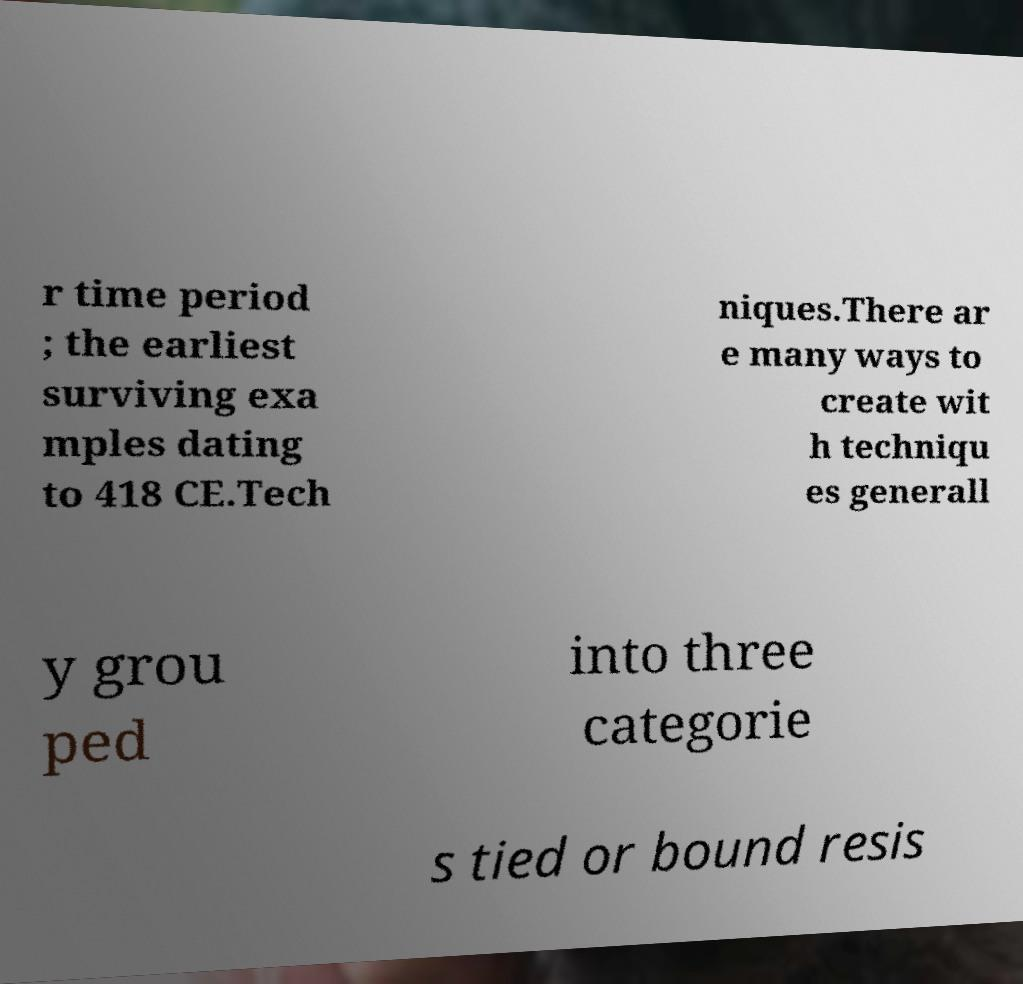Can you read and provide the text displayed in the image?This photo seems to have some interesting text. Can you extract and type it out for me? r time period ; the earliest surviving exa mples dating to 418 CE.Tech niques.There ar e many ways to create wit h techniqu es generall y grou ped into three categorie s tied or bound resis 